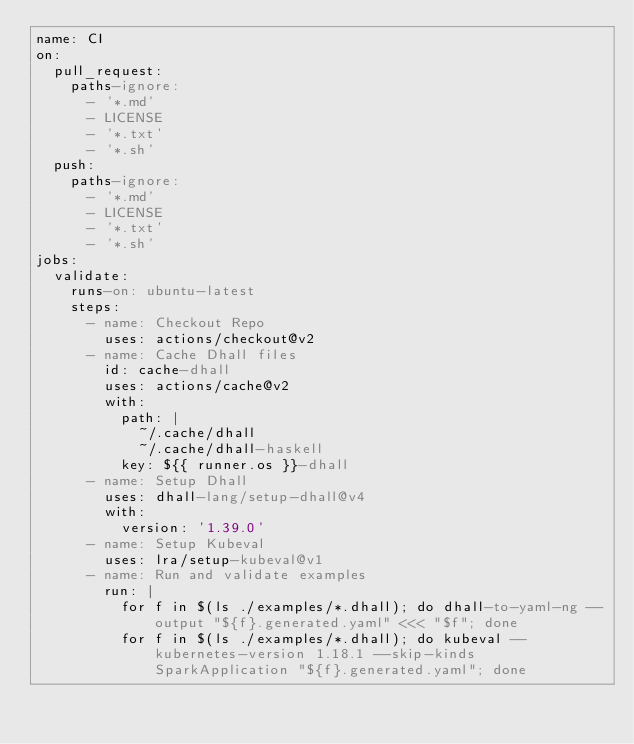<code> <loc_0><loc_0><loc_500><loc_500><_YAML_>name: CI
on:
  pull_request:
    paths-ignore:
      - '*.md'
      - LICENSE
      - '*.txt'
      - '*.sh'
  push:
    paths-ignore:
      - '*.md'
      - LICENSE
      - '*.txt'
      - '*.sh'
jobs:
  validate:
    runs-on: ubuntu-latest
    steps:
      - name: Checkout Repo
        uses: actions/checkout@v2
      - name: Cache Dhall files
        id: cache-dhall
        uses: actions/cache@v2
        with:
          path: |
            ~/.cache/dhall
            ~/.cache/dhall-haskell
          key: ${{ runner.os }}-dhall
      - name: Setup Dhall
        uses: dhall-lang/setup-dhall@v4
        with:
          version: '1.39.0'
      - name: Setup Kubeval
        uses: lra/setup-kubeval@v1
      - name: Run and validate examples
        run: |
          for f in $(ls ./examples/*.dhall); do dhall-to-yaml-ng --output "${f}.generated.yaml" <<< "$f"; done
          for f in $(ls ./examples/*.dhall); do kubeval --kubernetes-version 1.18.1 --skip-kinds SparkApplication "${f}.generated.yaml"; done</code> 